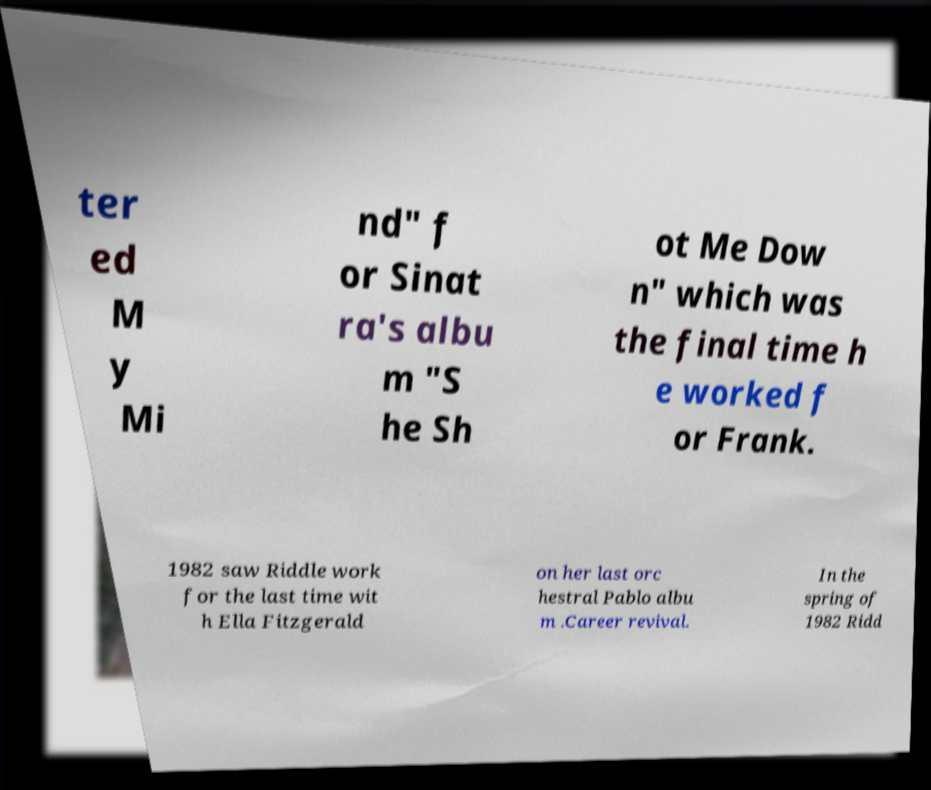Could you assist in decoding the text presented in this image and type it out clearly? ter ed M y Mi nd" f or Sinat ra's albu m "S he Sh ot Me Dow n" which was the final time h e worked f or Frank. 1982 saw Riddle work for the last time wit h Ella Fitzgerald on her last orc hestral Pablo albu m .Career revival. In the spring of 1982 Ridd 